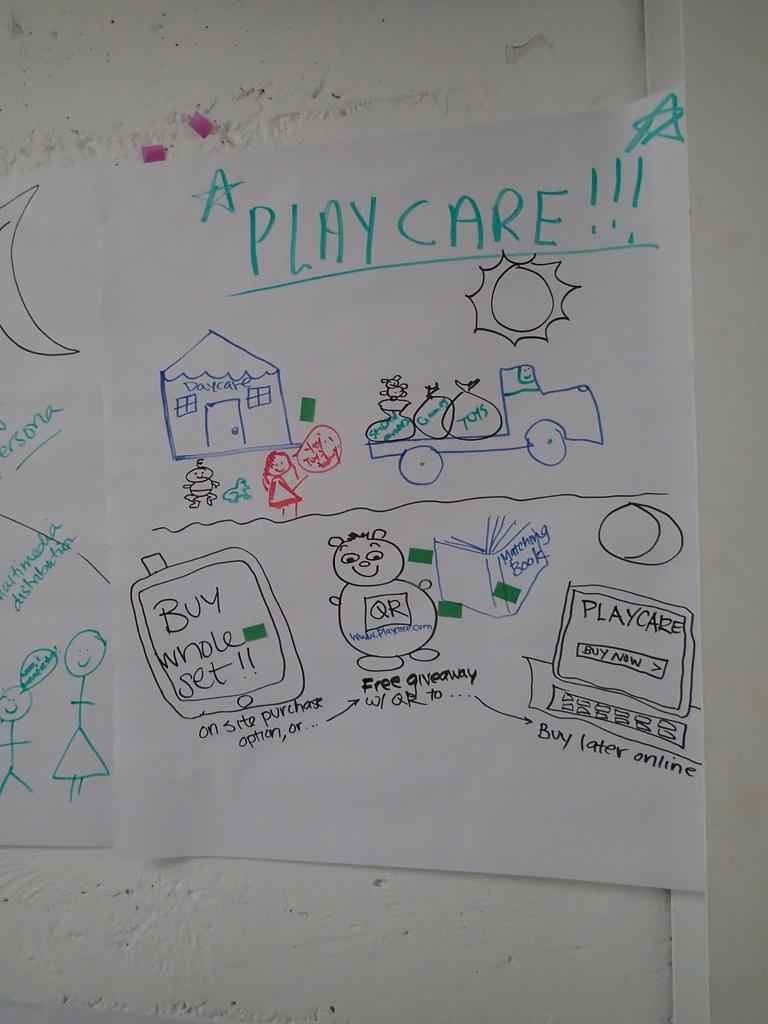What does the drawing depict?
Your response must be concise. Playcare. What does the cartoon bear have written on his chest?
Provide a succinct answer. Qr. 